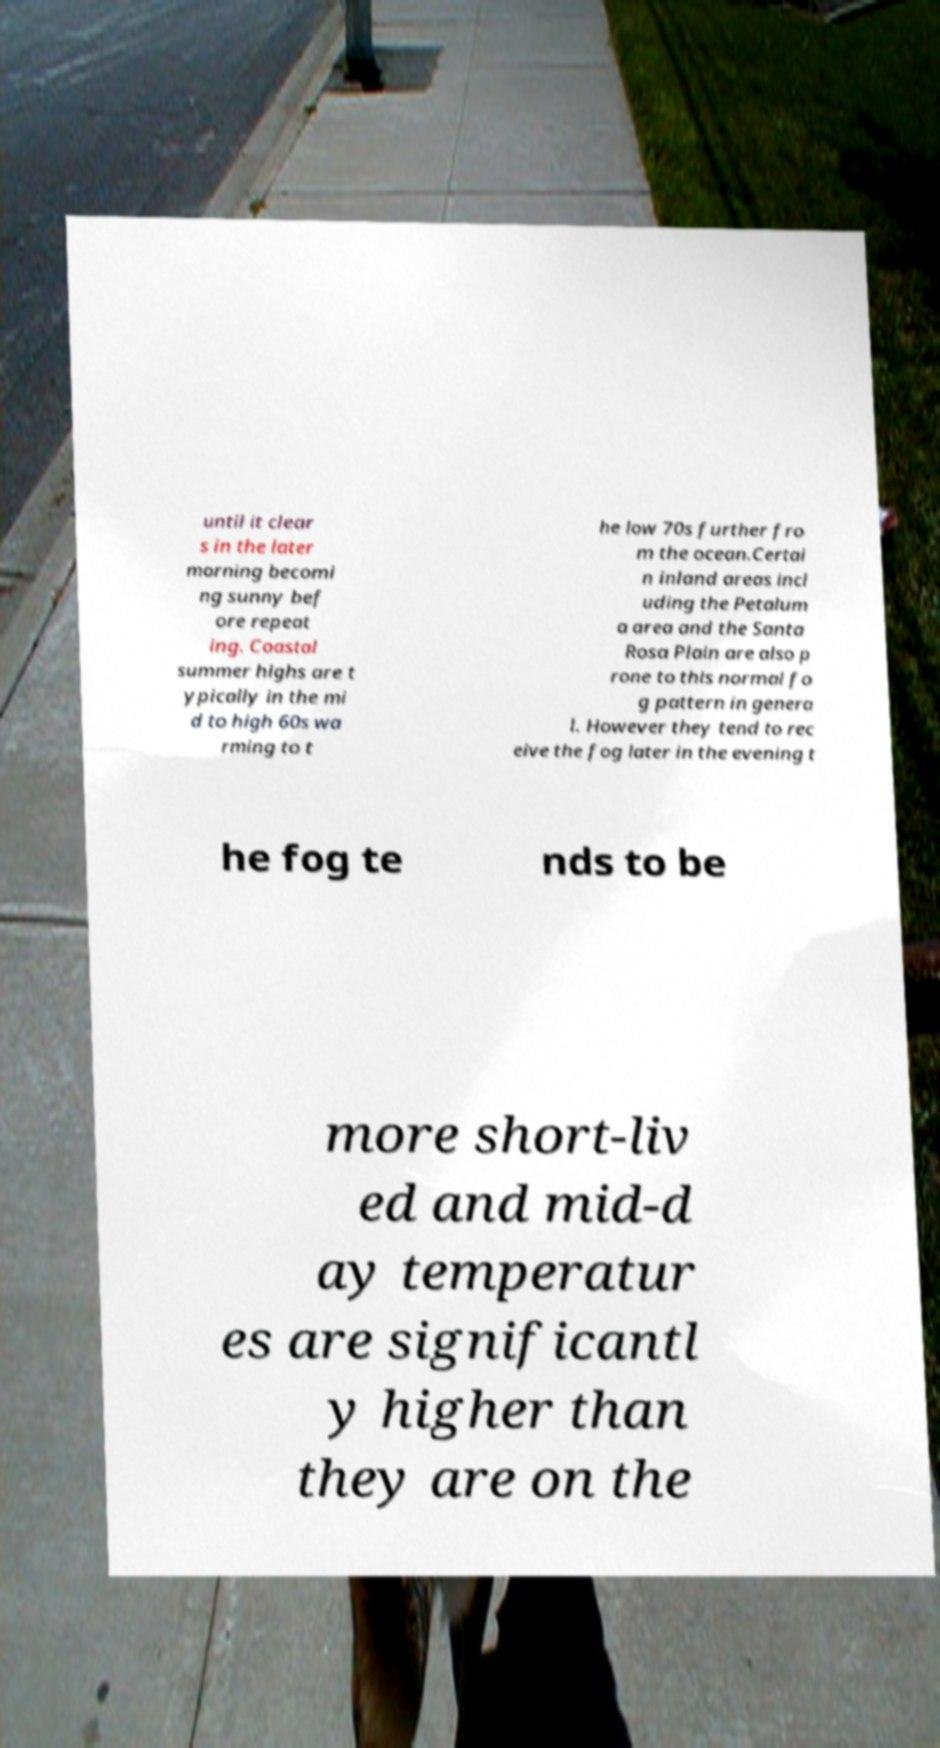Could you extract and type out the text from this image? until it clear s in the later morning becomi ng sunny bef ore repeat ing. Coastal summer highs are t ypically in the mi d to high 60s wa rming to t he low 70s further fro m the ocean.Certai n inland areas incl uding the Petalum a area and the Santa Rosa Plain are also p rone to this normal fo g pattern in genera l. However they tend to rec eive the fog later in the evening t he fog te nds to be more short-liv ed and mid-d ay temperatur es are significantl y higher than they are on the 